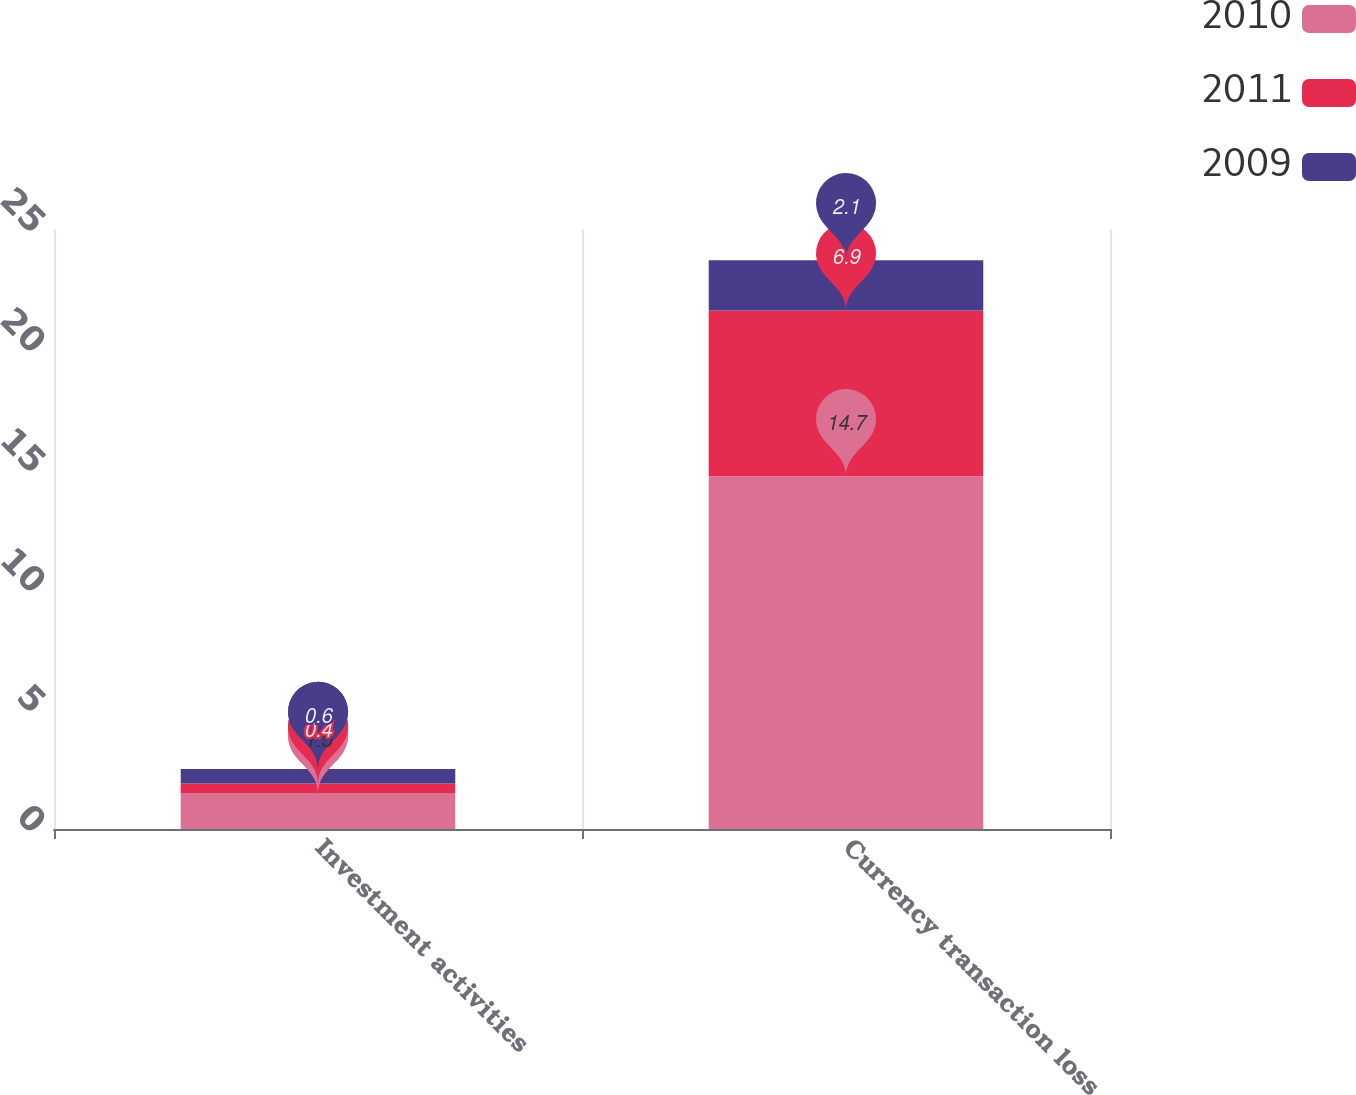Convert chart. <chart><loc_0><loc_0><loc_500><loc_500><stacked_bar_chart><ecel><fcel>Investment activities<fcel>Currency transaction loss<nl><fcel>2010<fcel>1.5<fcel>14.7<nl><fcel>2011<fcel>0.4<fcel>6.9<nl><fcel>2009<fcel>0.6<fcel>2.1<nl></chart> 